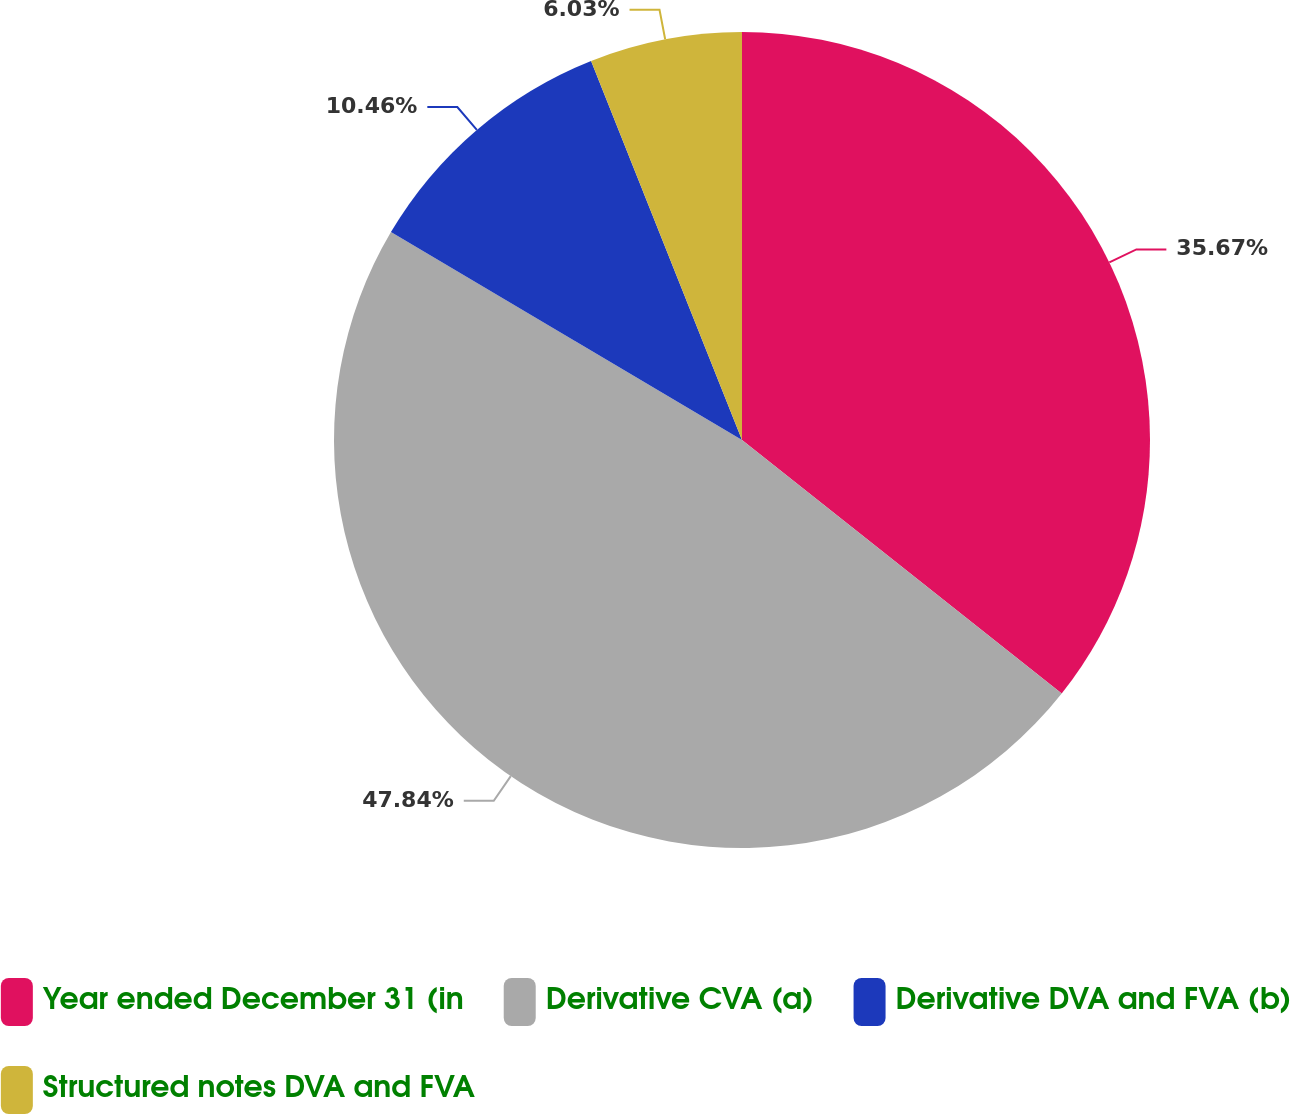<chart> <loc_0><loc_0><loc_500><loc_500><pie_chart><fcel>Year ended December 31 (in<fcel>Derivative CVA (a)<fcel>Derivative DVA and FVA (b)<fcel>Structured notes DVA and FVA<nl><fcel>35.67%<fcel>47.84%<fcel>10.46%<fcel>6.03%<nl></chart> 